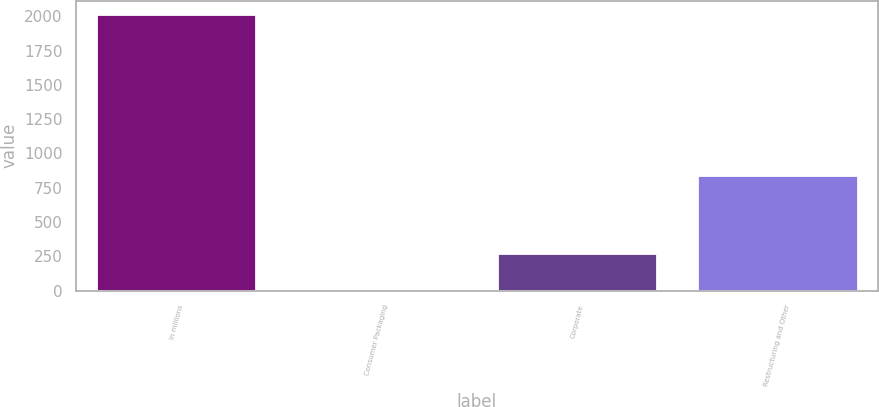<chart> <loc_0><loc_0><loc_500><loc_500><bar_chart><fcel>In millions<fcel>Consumer Packaging<fcel>Corporate<fcel>Restructuring and Other<nl><fcel>2014<fcel>8<fcel>277<fcel>846<nl></chart> 